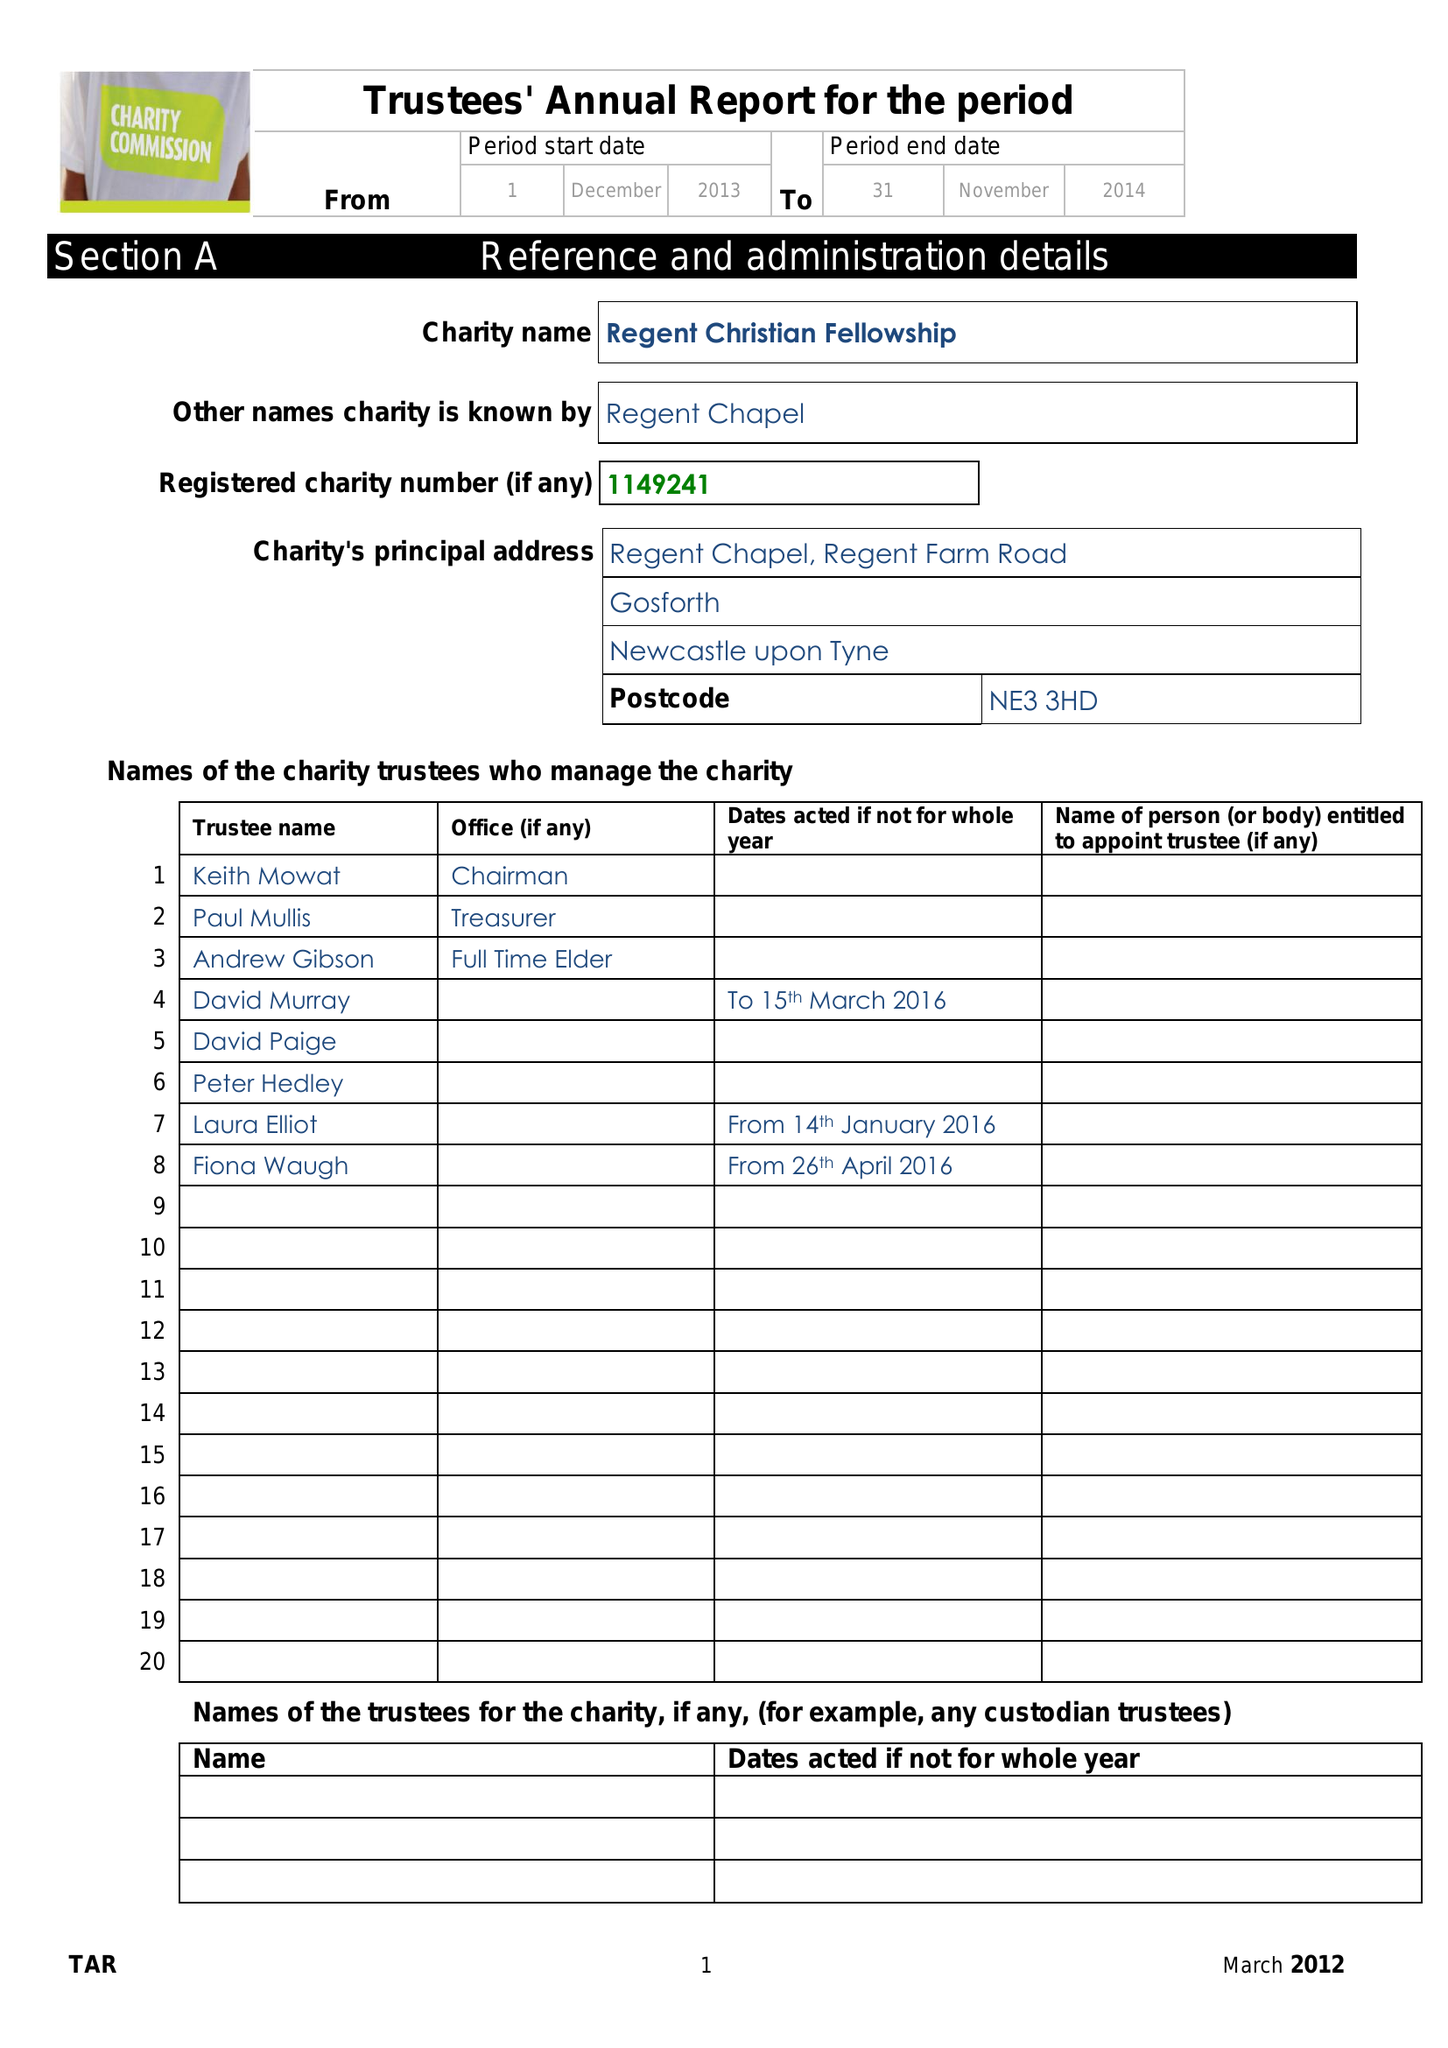What is the value for the address__post_town?
Answer the question using a single word or phrase. NEWCASTLE UPON TYNE 